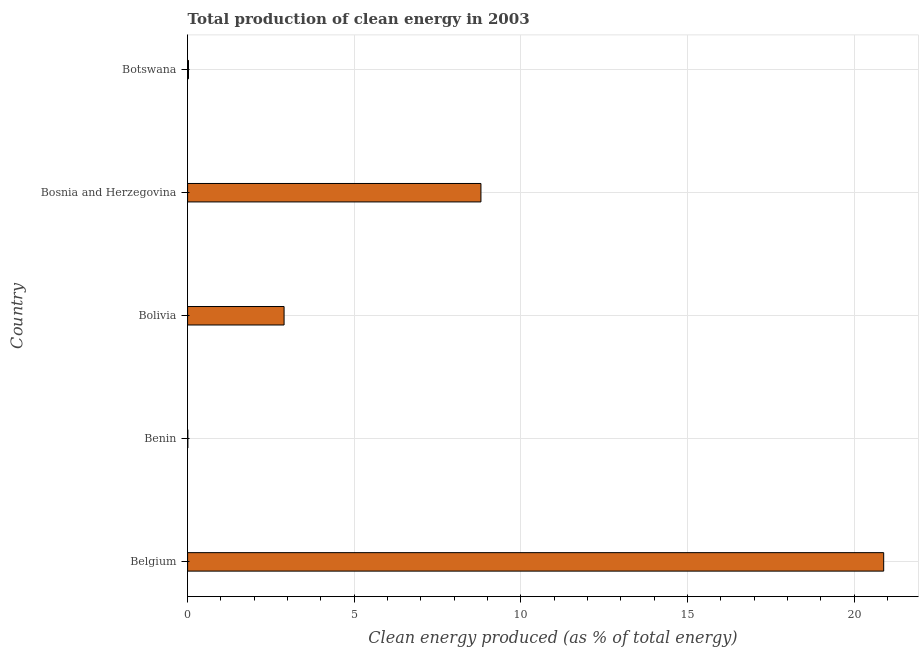What is the title of the graph?
Make the answer very short. Total production of clean energy in 2003. What is the label or title of the X-axis?
Give a very brief answer. Clean energy produced (as % of total energy). What is the production of clean energy in Botswana?
Provide a succinct answer. 0.03. Across all countries, what is the maximum production of clean energy?
Provide a short and direct response. 20.88. Across all countries, what is the minimum production of clean energy?
Ensure brevity in your answer.  0.01. In which country was the production of clean energy maximum?
Make the answer very short. Belgium. In which country was the production of clean energy minimum?
Give a very brief answer. Benin. What is the sum of the production of clean energy?
Offer a very short reply. 32.61. What is the difference between the production of clean energy in Belgium and Benin?
Ensure brevity in your answer.  20.87. What is the average production of clean energy per country?
Make the answer very short. 6.52. What is the median production of clean energy?
Your answer should be very brief. 2.89. What is the ratio of the production of clean energy in Benin to that in Bolivia?
Make the answer very short. 0. Is the production of clean energy in Benin less than that in Bolivia?
Offer a terse response. Yes. What is the difference between the highest and the second highest production of clean energy?
Provide a short and direct response. 12.08. Is the sum of the production of clean energy in Bosnia and Herzegovina and Botswana greater than the maximum production of clean energy across all countries?
Provide a short and direct response. No. What is the difference between the highest and the lowest production of clean energy?
Your answer should be very brief. 20.87. In how many countries, is the production of clean energy greater than the average production of clean energy taken over all countries?
Offer a very short reply. 2. How many bars are there?
Offer a very short reply. 5. Are all the bars in the graph horizontal?
Make the answer very short. Yes. How many countries are there in the graph?
Provide a short and direct response. 5. Are the values on the major ticks of X-axis written in scientific E-notation?
Your response must be concise. No. What is the Clean energy produced (as % of total energy) in Belgium?
Provide a succinct answer. 20.88. What is the Clean energy produced (as % of total energy) of Benin?
Give a very brief answer. 0.01. What is the Clean energy produced (as % of total energy) in Bolivia?
Provide a succinct answer. 2.89. What is the Clean energy produced (as % of total energy) of Bosnia and Herzegovina?
Offer a very short reply. 8.8. What is the Clean energy produced (as % of total energy) of Botswana?
Your answer should be compact. 0.03. What is the difference between the Clean energy produced (as % of total energy) in Belgium and Benin?
Make the answer very short. 20.87. What is the difference between the Clean energy produced (as % of total energy) in Belgium and Bolivia?
Offer a very short reply. 17.99. What is the difference between the Clean energy produced (as % of total energy) in Belgium and Bosnia and Herzegovina?
Offer a terse response. 12.08. What is the difference between the Clean energy produced (as % of total energy) in Belgium and Botswana?
Offer a terse response. 20.85. What is the difference between the Clean energy produced (as % of total energy) in Benin and Bolivia?
Provide a short and direct response. -2.89. What is the difference between the Clean energy produced (as % of total energy) in Benin and Bosnia and Herzegovina?
Ensure brevity in your answer.  -8.79. What is the difference between the Clean energy produced (as % of total energy) in Benin and Botswana?
Your response must be concise. -0.02. What is the difference between the Clean energy produced (as % of total energy) in Bolivia and Bosnia and Herzegovina?
Ensure brevity in your answer.  -5.91. What is the difference between the Clean energy produced (as % of total energy) in Bolivia and Botswana?
Your response must be concise. 2.87. What is the difference between the Clean energy produced (as % of total energy) in Bosnia and Herzegovina and Botswana?
Ensure brevity in your answer.  8.77. What is the ratio of the Clean energy produced (as % of total energy) in Belgium to that in Benin?
Your answer should be compact. 2896.04. What is the ratio of the Clean energy produced (as % of total energy) in Belgium to that in Bolivia?
Ensure brevity in your answer.  7.21. What is the ratio of the Clean energy produced (as % of total energy) in Belgium to that in Bosnia and Herzegovina?
Keep it short and to the point. 2.37. What is the ratio of the Clean energy produced (as % of total energy) in Belgium to that in Botswana?
Your response must be concise. 776.12. What is the ratio of the Clean energy produced (as % of total energy) in Benin to that in Bolivia?
Provide a short and direct response. 0. What is the ratio of the Clean energy produced (as % of total energy) in Benin to that in Bosnia and Herzegovina?
Keep it short and to the point. 0. What is the ratio of the Clean energy produced (as % of total energy) in Benin to that in Botswana?
Your response must be concise. 0.27. What is the ratio of the Clean energy produced (as % of total energy) in Bolivia to that in Bosnia and Herzegovina?
Your answer should be compact. 0.33. What is the ratio of the Clean energy produced (as % of total energy) in Bolivia to that in Botswana?
Provide a short and direct response. 107.57. What is the ratio of the Clean energy produced (as % of total energy) in Bosnia and Herzegovina to that in Botswana?
Your answer should be compact. 327.06. 